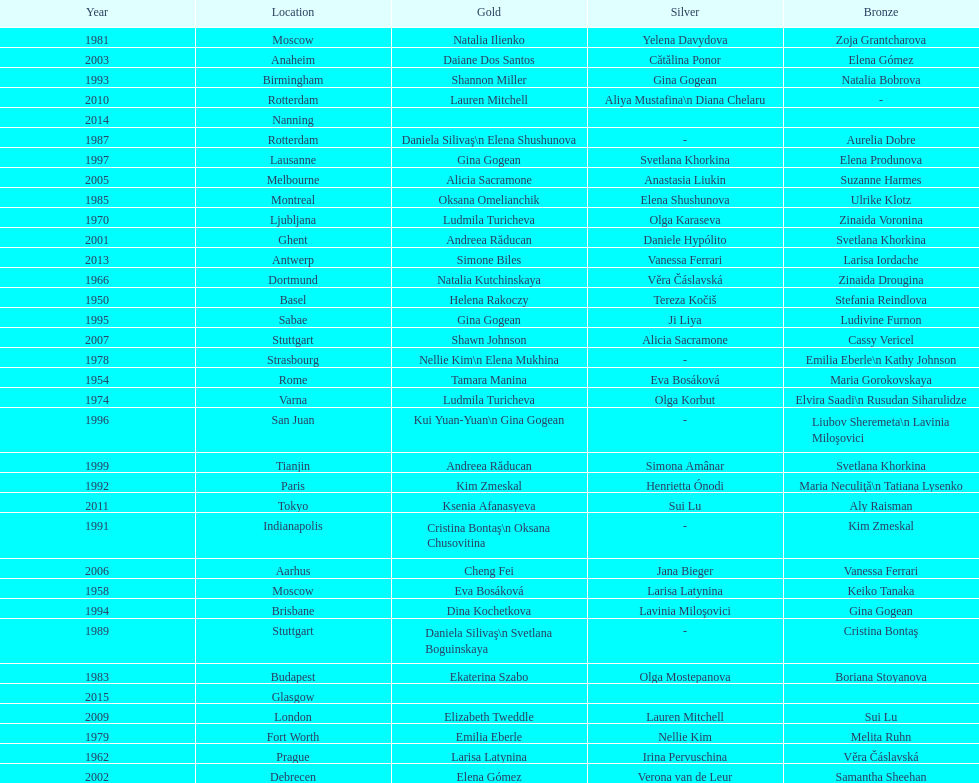Help me parse the entirety of this table. {'header': ['Year', 'Location', 'Gold', 'Silver', 'Bronze'], 'rows': [['1981', 'Moscow', 'Natalia Ilienko', 'Yelena Davydova', 'Zoja Grantcharova'], ['2003', 'Anaheim', 'Daiane Dos Santos', 'Cătălina Ponor', 'Elena Gómez'], ['1993', 'Birmingham', 'Shannon Miller', 'Gina Gogean', 'Natalia Bobrova'], ['2010', 'Rotterdam', 'Lauren Mitchell', 'Aliya Mustafina\\n Diana Chelaru', '-'], ['2014', 'Nanning', '', '', ''], ['1987', 'Rotterdam', 'Daniela Silivaş\\n Elena Shushunova', '-', 'Aurelia Dobre'], ['1997', 'Lausanne', 'Gina Gogean', 'Svetlana Khorkina', 'Elena Produnova'], ['2005', 'Melbourne', 'Alicia Sacramone', 'Anastasia Liukin', 'Suzanne Harmes'], ['1985', 'Montreal', 'Oksana Omelianchik', 'Elena Shushunova', 'Ulrike Klotz'], ['1970', 'Ljubljana', 'Ludmila Turicheva', 'Olga Karaseva', 'Zinaida Voronina'], ['2001', 'Ghent', 'Andreea Răducan', 'Daniele Hypólito', 'Svetlana Khorkina'], ['2013', 'Antwerp', 'Simone Biles', 'Vanessa Ferrari', 'Larisa Iordache'], ['1966', 'Dortmund', 'Natalia Kutchinskaya', 'Věra Čáslavská', 'Zinaida Drougina'], ['1950', 'Basel', 'Helena Rakoczy', 'Tereza Kočiš', 'Stefania Reindlova'], ['1995', 'Sabae', 'Gina Gogean', 'Ji Liya', 'Ludivine Furnon'], ['2007', 'Stuttgart', 'Shawn Johnson', 'Alicia Sacramone', 'Cassy Vericel'], ['1978', 'Strasbourg', 'Nellie Kim\\n Elena Mukhina', '-', 'Emilia Eberle\\n Kathy Johnson'], ['1954', 'Rome', 'Tamara Manina', 'Eva Bosáková', 'Maria Gorokovskaya'], ['1974', 'Varna', 'Ludmila Turicheva', 'Olga Korbut', 'Elvira Saadi\\n Rusudan Siharulidze'], ['1996', 'San Juan', 'Kui Yuan-Yuan\\n Gina Gogean', '-', 'Liubov Sheremeta\\n Lavinia Miloşovici'], ['1999', 'Tianjin', 'Andreea Răducan', 'Simona Amânar', 'Svetlana Khorkina'], ['1992', 'Paris', 'Kim Zmeskal', 'Henrietta Ónodi', 'Maria Neculiţă\\n Tatiana Lysenko'], ['2011', 'Tokyo', 'Ksenia Afanasyeva', 'Sui Lu', 'Aly Raisman'], ['1991', 'Indianapolis', 'Cristina Bontaş\\n Oksana Chusovitina', '-', 'Kim Zmeskal'], ['2006', 'Aarhus', 'Cheng Fei', 'Jana Bieger', 'Vanessa Ferrari'], ['1958', 'Moscow', 'Eva Bosáková', 'Larisa Latynina', 'Keiko Tanaka'], ['1994', 'Brisbane', 'Dina Kochetkova', 'Lavinia Miloşovici', 'Gina Gogean'], ['1989', 'Stuttgart', 'Daniela Silivaş\\n Svetlana Boguinskaya', '-', 'Cristina Bontaş'], ['1983', 'Budapest', 'Ekaterina Szabo', 'Olga Mostepanova', 'Boriana Stoyanova'], ['2015', 'Glasgow', '', '', ''], ['2009', 'London', 'Elizabeth Tweddle', 'Lauren Mitchell', 'Sui Lu'], ['1979', 'Fort Worth', 'Emilia Eberle', 'Nellie Kim', 'Melita Ruhn'], ['1962', 'Prague', 'Larisa Latynina', 'Irina Pervuschina', 'Věra Čáslavská'], ['2002', 'Debrecen', 'Elena Gómez', 'Verona van de Leur', 'Samantha Sheehan']]} Where did the world artistic gymnastics take place before san juan? Sabae. 